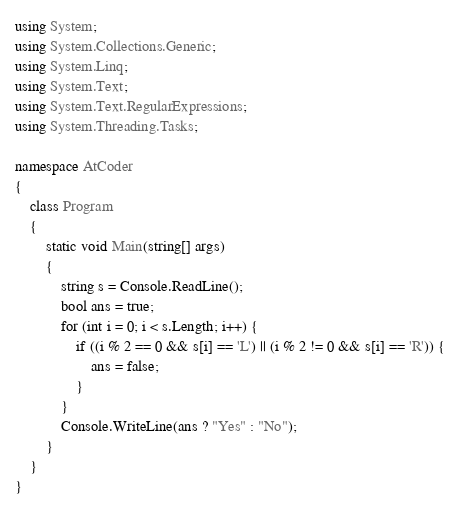Convert code to text. <code><loc_0><loc_0><loc_500><loc_500><_C#_>using System;
using System.Collections.Generic;
using System.Linq;
using System.Text;
using System.Text.RegularExpressions;
using System.Threading.Tasks;

namespace AtCoder
{
    class Program
    {
        static void Main(string[] args)
        {
            string s = Console.ReadLine();
            bool ans = true;
            for (int i = 0; i < s.Length; i++) {
                if ((i % 2 == 0 && s[i] == 'L') || (i % 2 != 0 && s[i] == 'R')) {
                    ans = false;
                }
            }
            Console.WriteLine(ans ? "Yes" : "No");
        }
    }
}
</code> 